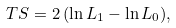Convert formula to latex. <formula><loc_0><loc_0><loc_500><loc_500>T S = 2 \, ( \ln L _ { 1 } - \ln L _ { 0 } ) ,</formula> 